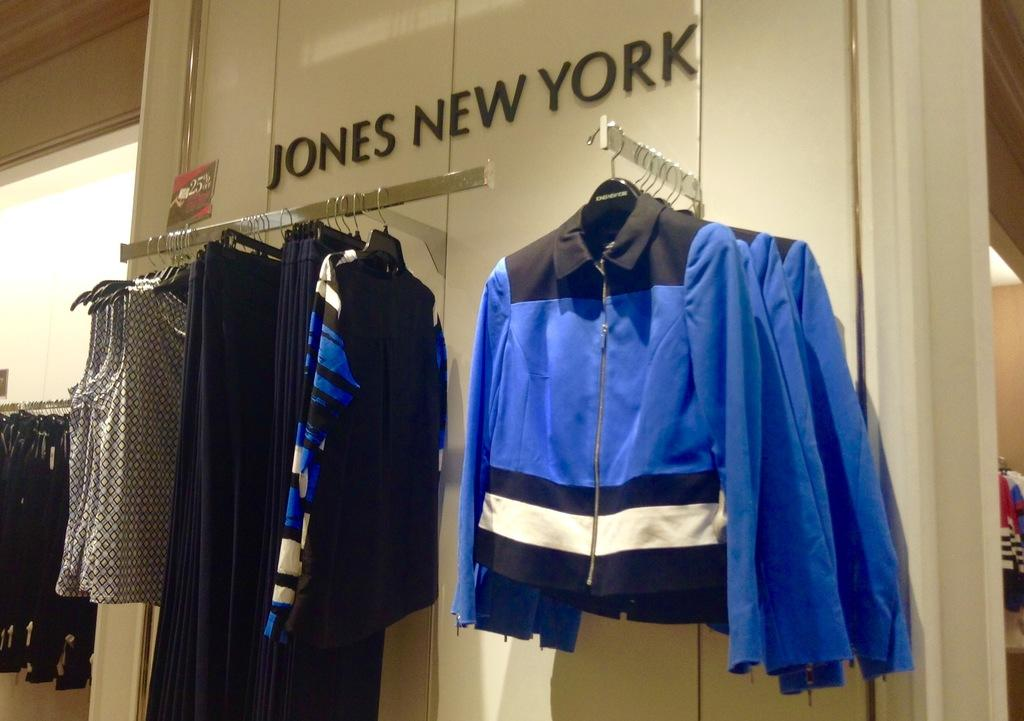<image>
Write a terse but informative summary of the picture. Pants, tops, and jackets for sale at Jones New York. 